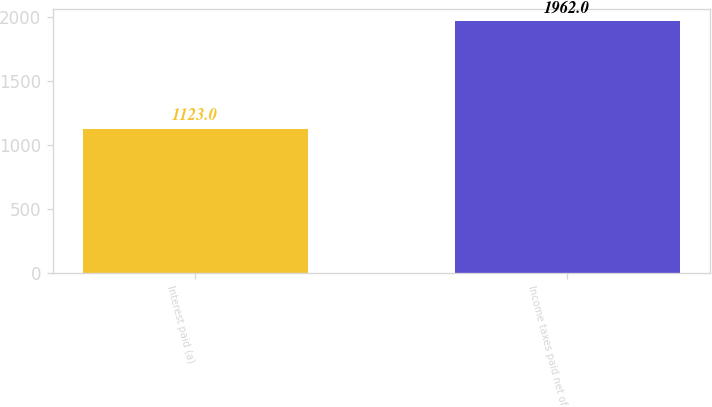Convert chart to OTSL. <chart><loc_0><loc_0><loc_500><loc_500><bar_chart><fcel>Interest paid (a)<fcel>Income taxes paid net of<nl><fcel>1123<fcel>1962<nl></chart> 